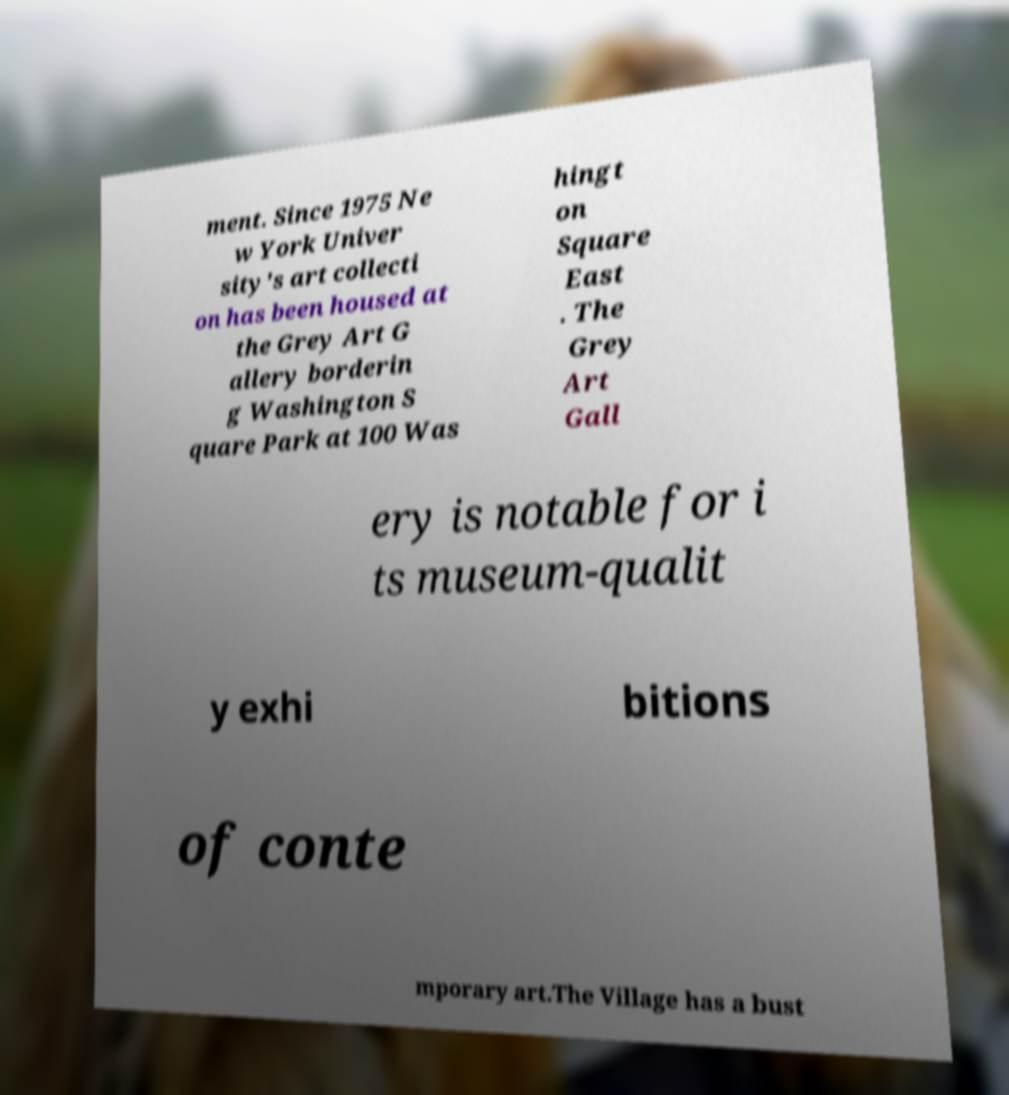Please read and relay the text visible in this image. What does it say? ment. Since 1975 Ne w York Univer sity's art collecti on has been housed at the Grey Art G allery borderin g Washington S quare Park at 100 Was hingt on Square East . The Grey Art Gall ery is notable for i ts museum-qualit y exhi bitions of conte mporary art.The Village has a bust 